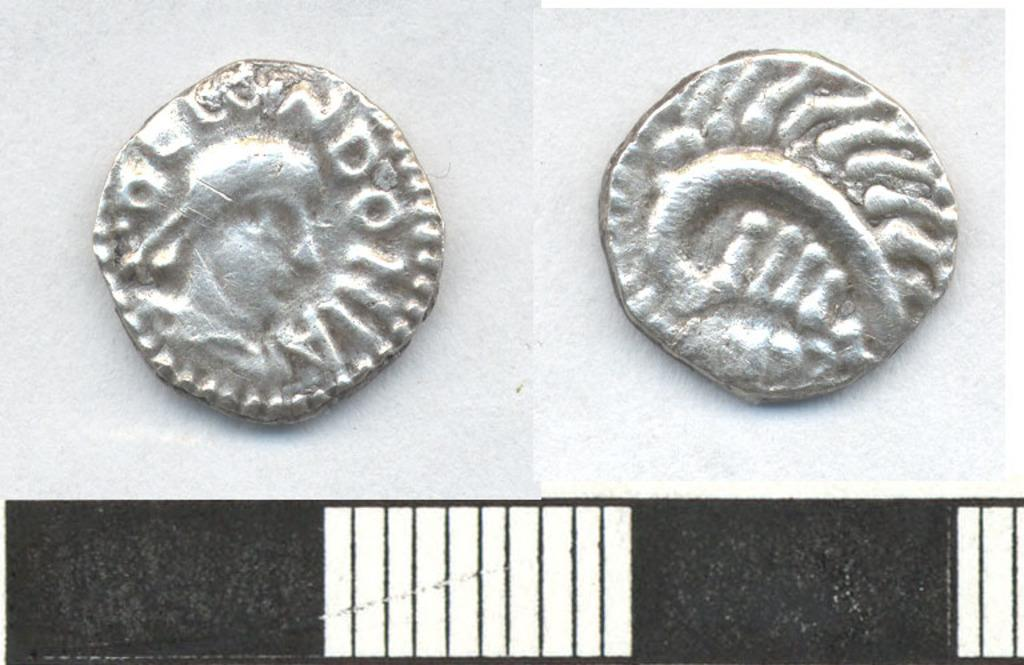What objects are present in the image? There are two silver coins in the image. What can be found on the surface of the coins? The coins have shapes on them. What is the color of the lines in the image? The lines in the image are white. What is the color of the background in the image? The background is black. Can you tell me where the carriage is located in the image? There is no carriage present in the image. What type of ornament is hanging from the cactus in the image? There is no cactus or ornament present in the image. 